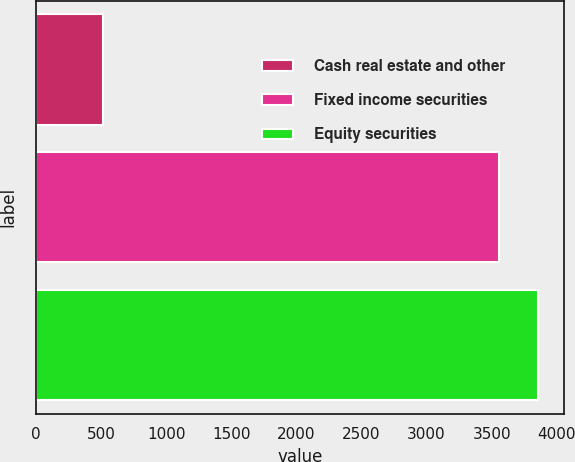Convert chart. <chart><loc_0><loc_0><loc_500><loc_500><bar_chart><fcel>Cash real estate and other<fcel>Fixed income securities<fcel>Equity securities<nl><fcel>515<fcel>3555<fcel>3859<nl></chart> 